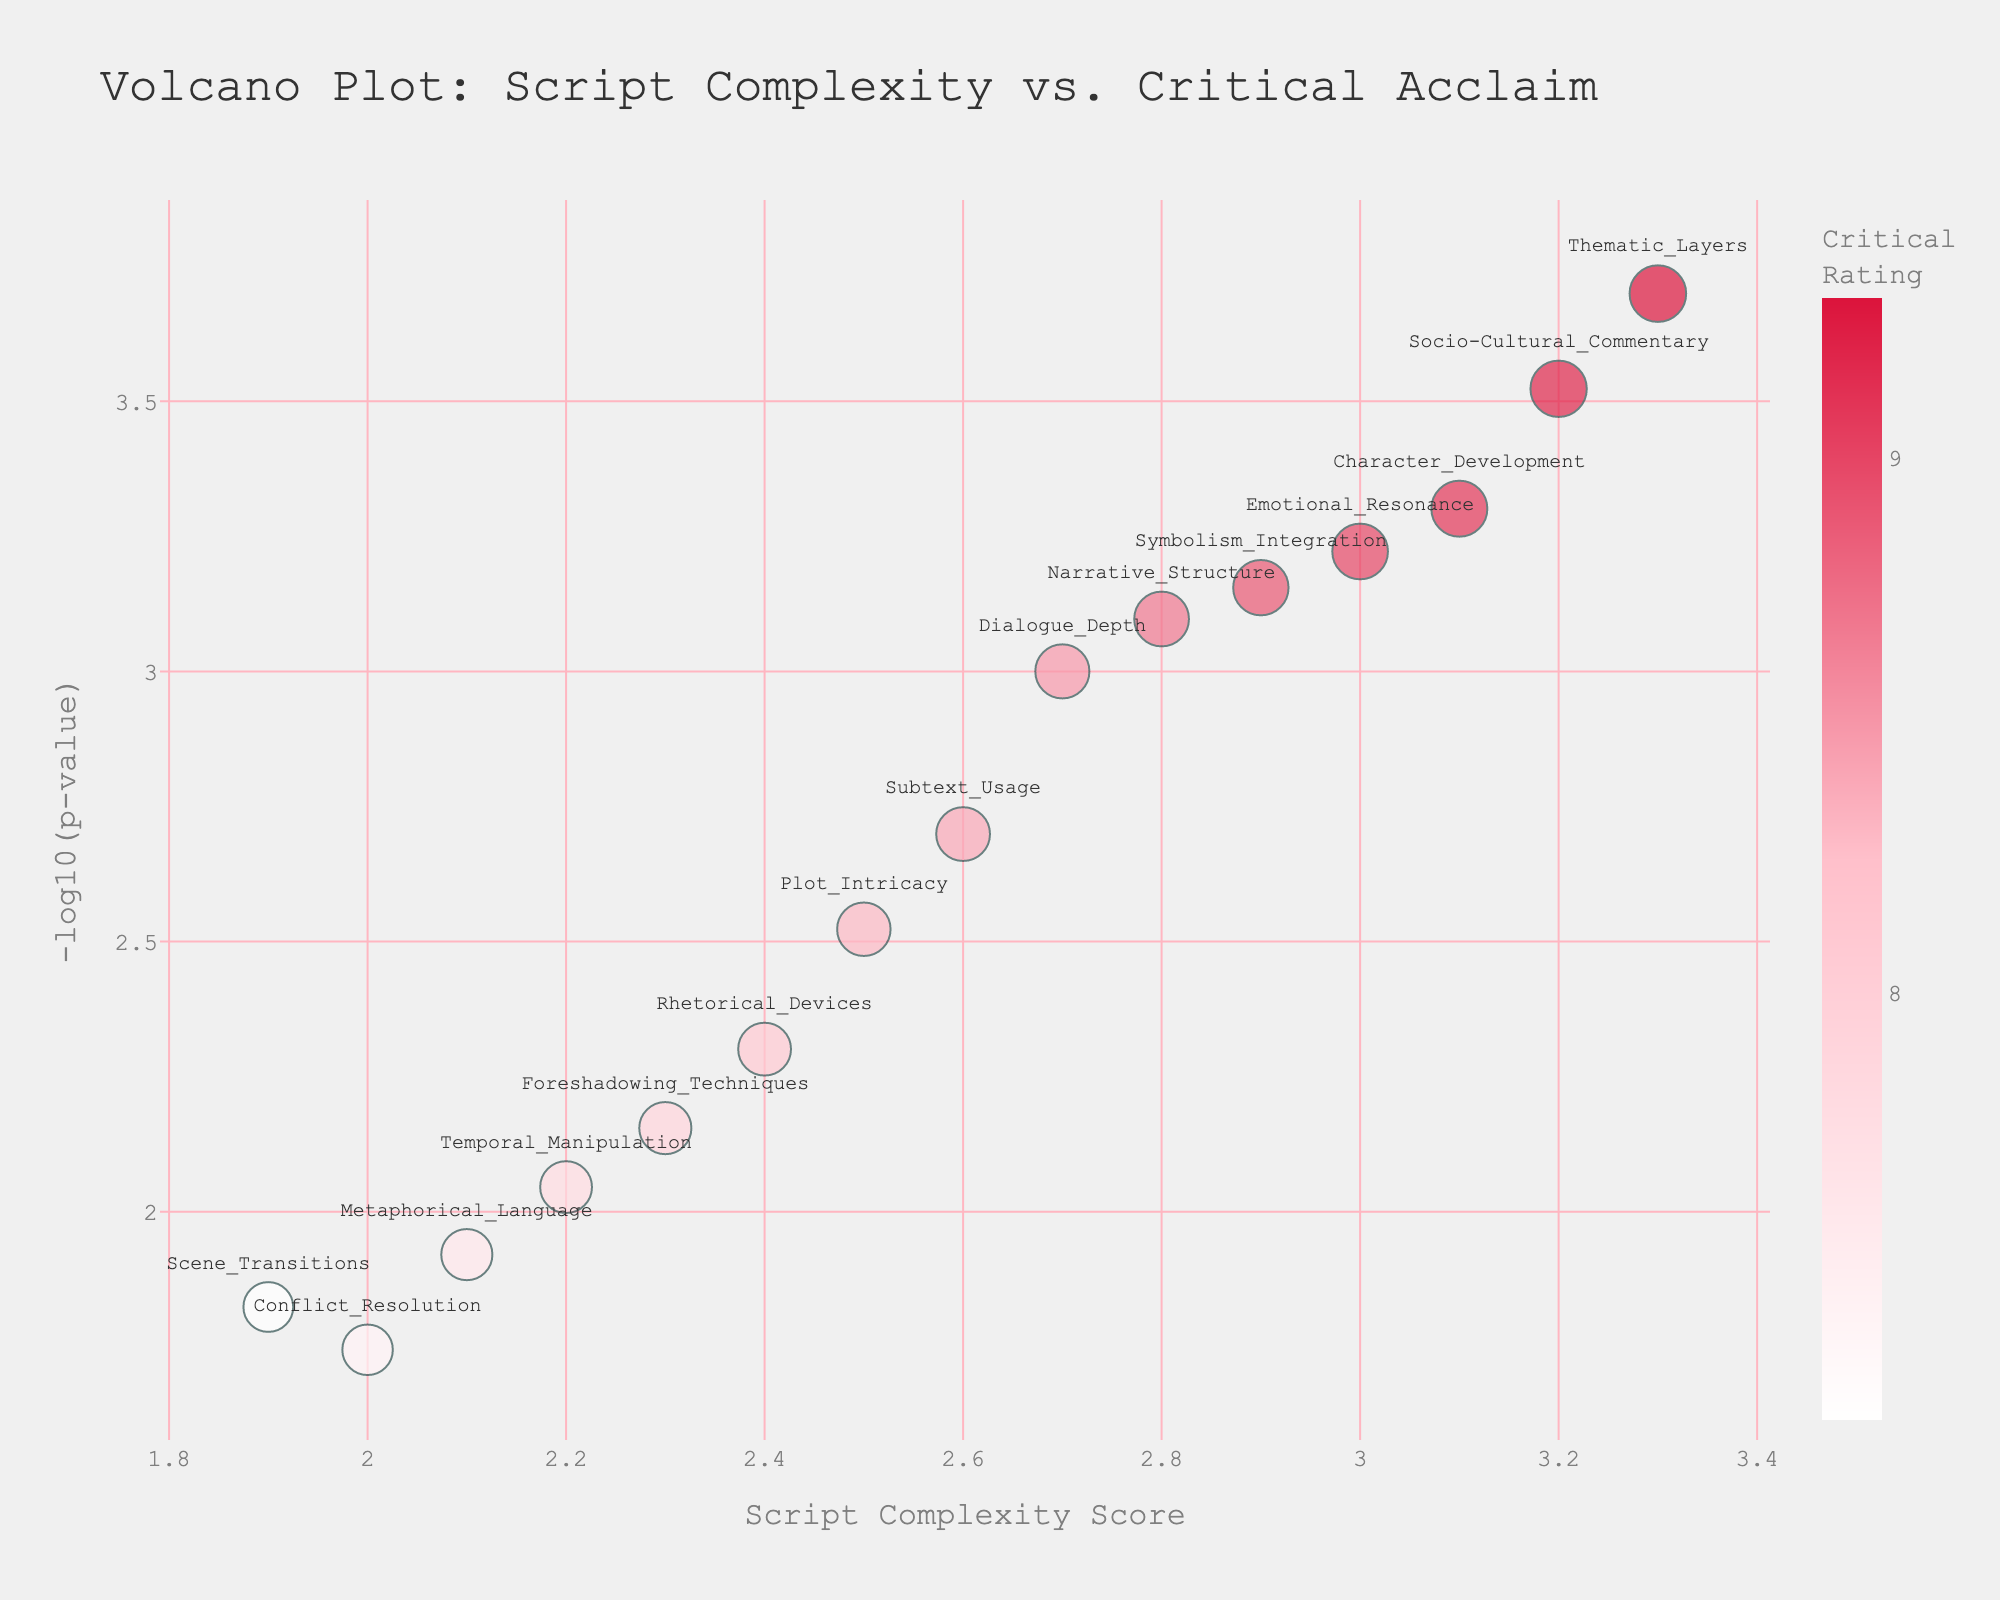What is the title of the plot? The title of the plot is displayed at the top of the figure. It provides context and a brief description of what the plot is about.
Answer: Volcano Plot: Script Complexity vs. Critical Acclaim How many data points are plotted? Each 'Script_Element' represents a data point. By counting all unique elements, we can determine the total number of points.
Answer: 15 Which script element has the highest Critical Rating? By observing the sizes of the points (which reflect the Critical Rating), the largest point corresponds to 'Thematic Layers'.
Answer: Thematic Layers What is the y-axis representing? The y-axis is labeled with '-log10(p-value)', indicating it shows the negative logarithm to the base 10 of the p-values for each data point.
Answer: -log10(p-value) Which script element has the highest complexity score? The highest position on the x-axis, labeled 'Script Complexity Score', represents the highest complexity score. The corresponding 'Script_Element' is identified as 'Thematic Layers'.
Answer: Thematic Layers How does the color scale relate to the Critical Rating? The figure uses a continuous color scale transitioning from white to pink to crimson. Darker shades indicate higher Critical Ratings on the points.
Answer: Darker shades indicate higher Critical Ratings What is the -log10(p-value) for 'Narrative Structure'? Locate the 'Narrative Structure' point and check the y-axis value it aligns with. The y-axis represents -log10(p-value).
Answer: 3.09 Compare the Critical Ratings of 'Character Development' and 'Conflict Resolution'. Which one is higher? Find the points for both 'Character Development' and 'Conflict Resolution'. Compare their sizes, as larger points indicate higher Critical Ratings.
Answer: Character Development What range is used for the color axis of Critical Ratings? The color scale legend shows tickmarks at 7, 8, and 9, indicating the range.
Answer: 7 to 9 Determine the average Complexity Score of 'Dialogue Depth' and 'Foreshadowing Techniques'. Sum the Complexity Scores of 'Dialogue Depth' and 'Foreshadowing Techniques' (2.7 + 2.3) and divide by 2. (2.7 + 2.3)/2 = 2.5
Answer: 2.5 